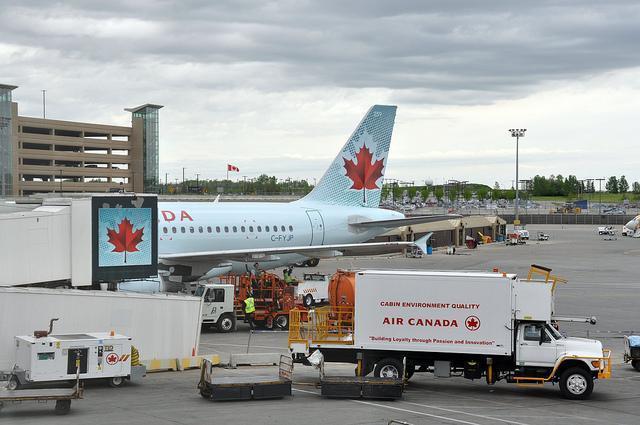How many people are wearing bright yellow vests?
Give a very brief answer. 1. How many trucks are there?
Give a very brief answer. 2. 